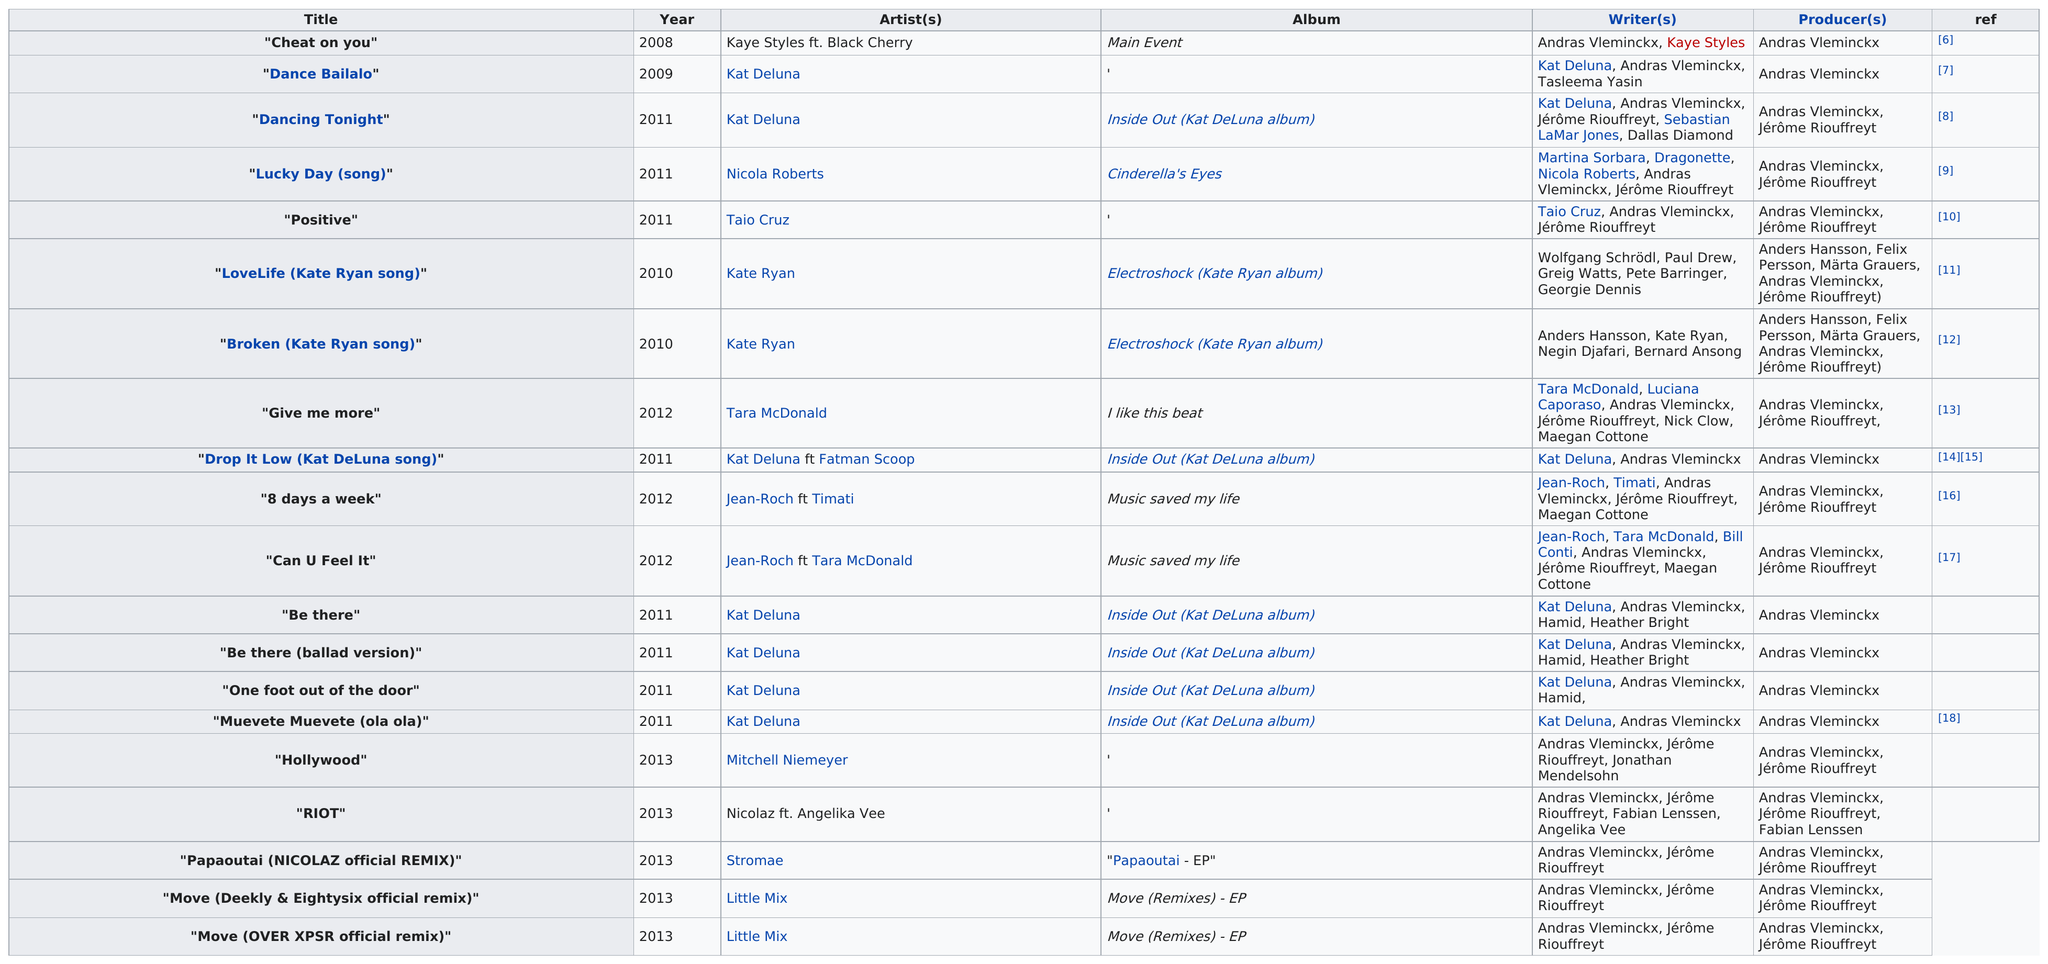Highlight a few significant elements in this photo. Eightysix has been credited for a total of 20 songs. Which producer had the most titles? It was Andras Vleminckx. This producer has a total of 20 producing credits. There are 20 titles in total. The quantity of songs that a particular producer worked with Taio Cruz on is 1. 